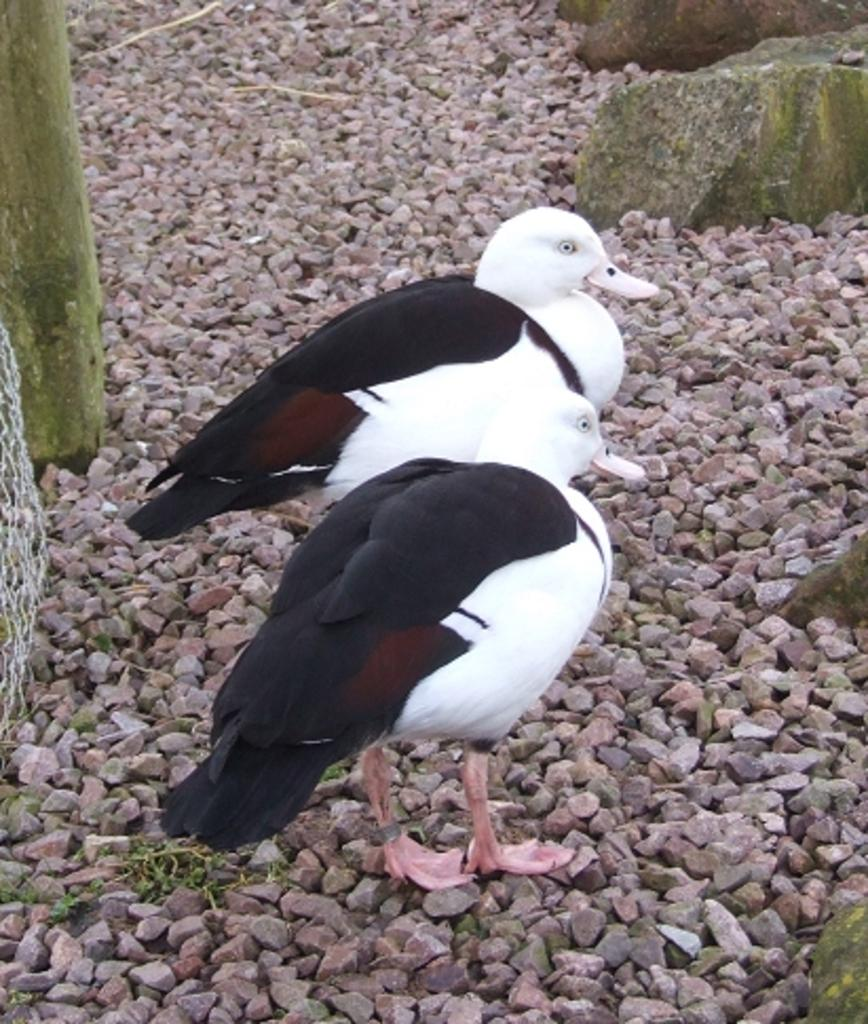What type of material is present in the image? There are gravel stones and rocks in the image. What type of living organisms can be seen in the image? Birds can be seen in the image. What is the purpose of the net in the image? The purpose of the net in the image is not specified, but it could be used for catching birds or for some other purpose. What type of container is present in the image? There is a trunk in the image. What type of pet can be seen in the image? There is no pet visible in the image. What type of pleasure can be derived from the image? The image does not depict any specific pleasure or activity. What type of food is being consumed by the birds in the image? The image does not show the birds consuming any food, including their mouths. 